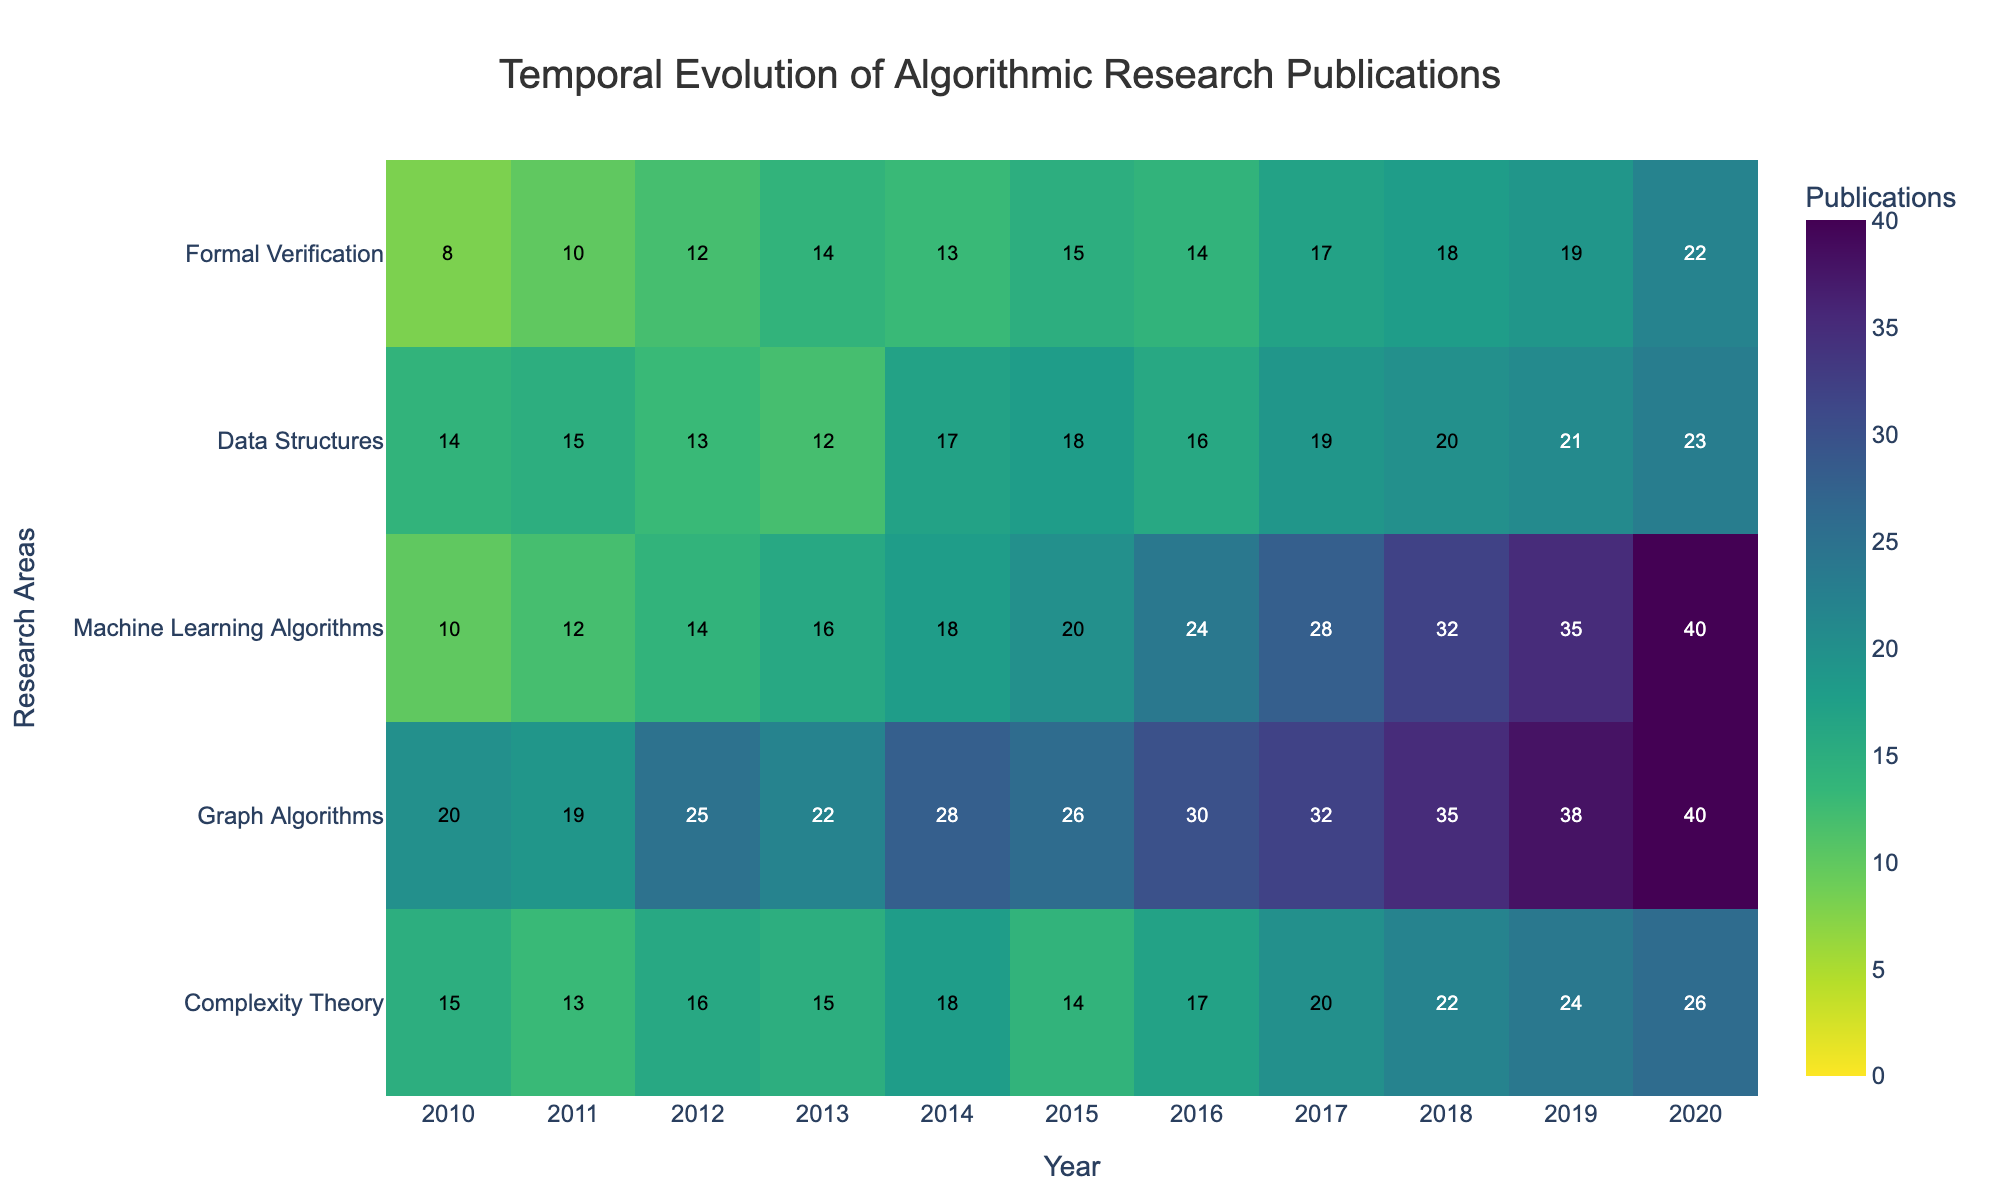What is the title of the heatmap? The title is located at the top center of the heatmap, it reads ‘Temporal Evolution of Algorithmic Research Publications’.
Answer: Temporal Evolution of Algorithmic Research Publications Which year had the highest number of publications in Machine Learning Algorithms? Look at the row labeled 'Machine Learning Algorithms' and find the maximum value. The highest number is 40 and it occurs in the year 2020.
Answer: 2020 How did the number of publications in Graph Algorithms evolve from 2010 to 2020? Check the row labeled 'Graph Algorithms' and note the values from 2010 to 2020: [20, 19, 25, 22, 28, 26, 30, 32, 35, 38, 40]. Observe the increasing trend over the years.
Answer: Increasing Which research area had the smallest number of publications overall in 2010? Check the values in the 2010 column for each research area. The smallest number is 8 in the 'Formal Verification' area.
Answer: Formal Verification What is the sum of publications in Complexity Theory and Data Structures in 2015? Find the values in the 2015 row for both 'Complexity Theory' and 'Data Structures': 14 and 18. Add them to get 14 + 18 = 32.
Answer: 32 In which year did Formal Verification surpass 15 publications for the first time? Examine the values in the row 'Formal Verification' year by year and identify when they first exceed 15. The year is 2020 with 22 publications.
Answer: 2020 Which two research areas had the closest number of publications in 2013? Compare the values in the 2013 column: Complexity Theory (15), Graph Algorithms (22), Machine Learning Algorithms (16), Data Structures (12), Formal Verification (14). The closest numbers are Machine Learning Algorithms and Formal Verification (16 and 14 respectively).
Answer: Machine Learning Algorithms and Formal Verification What is the average number of publications in Data Structures from 2010 to 2020? Sum the values in the row 'Data Structures' and divide by the number of years (11): (14+15+13+12+17+18+16+19+20+21+23)/11 = 16.27
Answer: 16.27 Between 2016 and 2019, which research area showed the most significant increase in publications? Calculate the difference for each area between 2016 and 2019: Complexity Theory (24-17=7), Graph Algorithms (38-30=8), Machine Learning Algorithms (35-24=11), Data Structures (21-16=5), Formal Verification (19-14=5). The largest increase is in Machine Learning Algorithms with 11.
Answer: Machine Learning Algorithms How many total publications were there across all research areas in 2017? Sum the values for all areas in the 2017 column: 20 + 32 + 28 + 19 + 17 = 116.
Answer: 116 